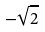Convert formula to latex. <formula><loc_0><loc_0><loc_500><loc_500>- \sqrt { 2 }</formula> 